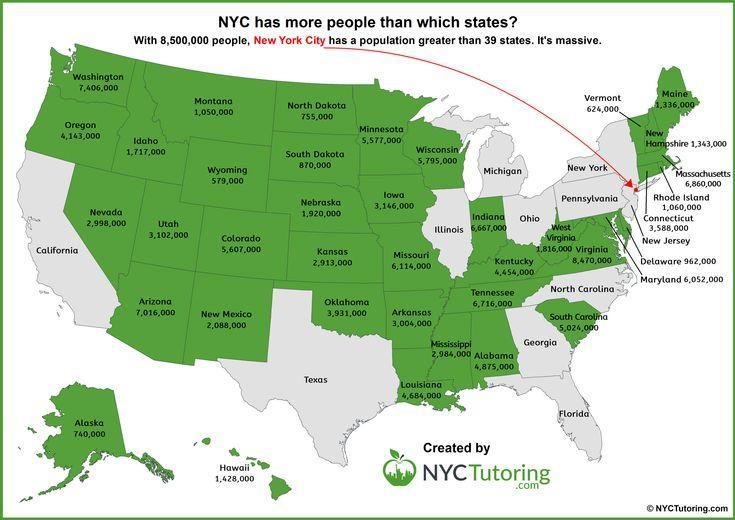What is the population of Alaska?
Answer the question with a short phrase. 740,000 Which city in U.S. has the largest population? New York City, NYC What is the population of Iowa? 3,146,000 